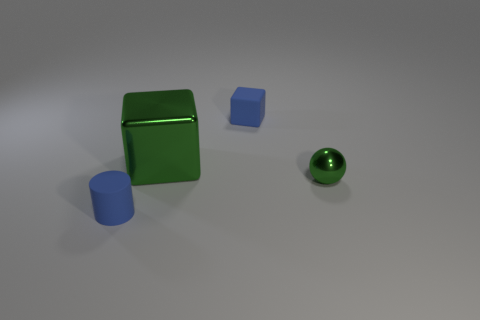Add 4 tiny metal objects. How many objects exist? 8 Add 2 large cubes. How many large cubes are left? 3 Add 1 spheres. How many spheres exist? 2 Subtract all green cubes. How many cubes are left? 1 Subtract 0 blue spheres. How many objects are left? 4 Subtract all cylinders. How many objects are left? 3 Subtract 1 balls. How many balls are left? 0 Subtract all yellow cylinders. Subtract all brown spheres. How many cylinders are left? 1 Subtract all gray spheres. How many blue blocks are left? 1 Subtract all metallic things. Subtract all large blocks. How many objects are left? 1 